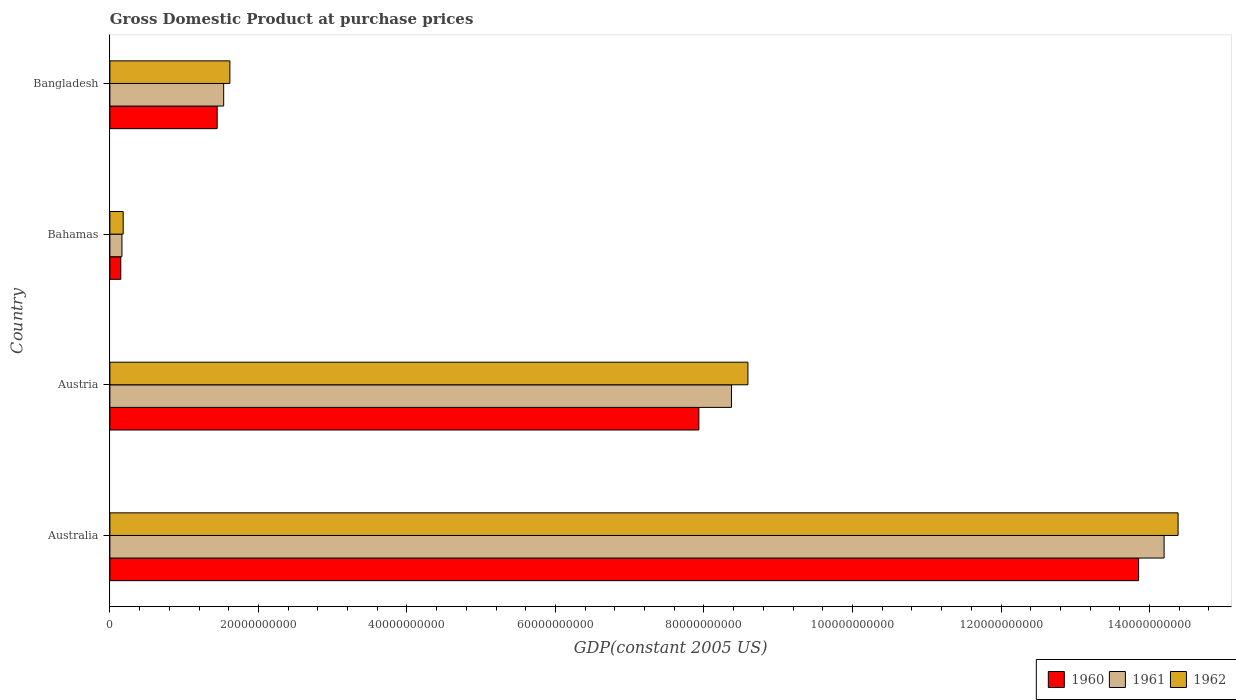How many different coloured bars are there?
Make the answer very short. 3. Are the number of bars per tick equal to the number of legend labels?
Ensure brevity in your answer.  Yes. How many bars are there on the 2nd tick from the top?
Offer a very short reply. 3. What is the label of the 1st group of bars from the top?
Give a very brief answer. Bangladesh. In how many cases, is the number of bars for a given country not equal to the number of legend labels?
Ensure brevity in your answer.  0. What is the GDP at purchase prices in 1960 in Bangladesh?
Offer a terse response. 1.44e+1. Across all countries, what is the maximum GDP at purchase prices in 1962?
Make the answer very short. 1.44e+11. Across all countries, what is the minimum GDP at purchase prices in 1962?
Ensure brevity in your answer.  1.79e+09. In which country was the GDP at purchase prices in 1962 minimum?
Offer a very short reply. Bahamas. What is the total GDP at purchase prices in 1962 in the graph?
Give a very brief answer. 2.48e+11. What is the difference between the GDP at purchase prices in 1960 in Australia and that in Bangladesh?
Offer a terse response. 1.24e+11. What is the difference between the GDP at purchase prices in 1960 in Bahamas and the GDP at purchase prices in 1962 in Australia?
Your answer should be very brief. -1.42e+11. What is the average GDP at purchase prices in 1962 per country?
Offer a very short reply. 6.19e+1. What is the difference between the GDP at purchase prices in 1960 and GDP at purchase prices in 1961 in Bangladesh?
Provide a succinct answer. -8.75e+08. In how many countries, is the GDP at purchase prices in 1961 greater than 24000000000 US$?
Give a very brief answer. 2. What is the ratio of the GDP at purchase prices in 1962 in Austria to that in Bangladesh?
Your response must be concise. 5.32. Is the GDP at purchase prices in 1960 in Australia less than that in Austria?
Your response must be concise. No. What is the difference between the highest and the second highest GDP at purchase prices in 1962?
Keep it short and to the point. 5.79e+1. What is the difference between the highest and the lowest GDP at purchase prices in 1962?
Your answer should be compact. 1.42e+11. What does the 3rd bar from the top in Australia represents?
Your answer should be very brief. 1960. What does the 3rd bar from the bottom in Bahamas represents?
Provide a short and direct response. 1962. Is it the case that in every country, the sum of the GDP at purchase prices in 1961 and GDP at purchase prices in 1962 is greater than the GDP at purchase prices in 1960?
Provide a succinct answer. Yes. Are all the bars in the graph horizontal?
Your answer should be compact. Yes. How many countries are there in the graph?
Provide a short and direct response. 4. What is the difference between two consecutive major ticks on the X-axis?
Keep it short and to the point. 2.00e+1. Are the values on the major ticks of X-axis written in scientific E-notation?
Your answer should be compact. No. Does the graph contain any zero values?
Offer a terse response. No. Does the graph contain grids?
Your answer should be very brief. No. Where does the legend appear in the graph?
Your answer should be very brief. Bottom right. What is the title of the graph?
Keep it short and to the point. Gross Domestic Product at purchase prices. Does "1960" appear as one of the legend labels in the graph?
Keep it short and to the point. Yes. What is the label or title of the X-axis?
Keep it short and to the point. GDP(constant 2005 US). What is the GDP(constant 2005 US) in 1960 in Australia?
Keep it short and to the point. 1.39e+11. What is the GDP(constant 2005 US) of 1961 in Australia?
Ensure brevity in your answer.  1.42e+11. What is the GDP(constant 2005 US) of 1962 in Australia?
Offer a terse response. 1.44e+11. What is the GDP(constant 2005 US) in 1960 in Austria?
Offer a terse response. 7.93e+1. What is the GDP(constant 2005 US) of 1961 in Austria?
Give a very brief answer. 8.37e+1. What is the GDP(constant 2005 US) in 1962 in Austria?
Make the answer very short. 8.59e+1. What is the GDP(constant 2005 US) of 1960 in Bahamas?
Your response must be concise. 1.47e+09. What is the GDP(constant 2005 US) in 1961 in Bahamas?
Your answer should be compact. 1.62e+09. What is the GDP(constant 2005 US) of 1962 in Bahamas?
Your answer should be very brief. 1.79e+09. What is the GDP(constant 2005 US) in 1960 in Bangladesh?
Keep it short and to the point. 1.44e+1. What is the GDP(constant 2005 US) of 1961 in Bangladesh?
Your response must be concise. 1.53e+1. What is the GDP(constant 2005 US) of 1962 in Bangladesh?
Offer a very short reply. 1.62e+1. Across all countries, what is the maximum GDP(constant 2005 US) of 1960?
Give a very brief answer. 1.39e+11. Across all countries, what is the maximum GDP(constant 2005 US) of 1961?
Your response must be concise. 1.42e+11. Across all countries, what is the maximum GDP(constant 2005 US) of 1962?
Keep it short and to the point. 1.44e+11. Across all countries, what is the minimum GDP(constant 2005 US) of 1960?
Your response must be concise. 1.47e+09. Across all countries, what is the minimum GDP(constant 2005 US) of 1961?
Provide a succinct answer. 1.62e+09. Across all countries, what is the minimum GDP(constant 2005 US) of 1962?
Ensure brevity in your answer.  1.79e+09. What is the total GDP(constant 2005 US) of 1960 in the graph?
Keep it short and to the point. 2.34e+11. What is the total GDP(constant 2005 US) of 1961 in the graph?
Your answer should be very brief. 2.43e+11. What is the total GDP(constant 2005 US) in 1962 in the graph?
Offer a very short reply. 2.48e+11. What is the difference between the GDP(constant 2005 US) in 1960 in Australia and that in Austria?
Offer a very short reply. 5.92e+1. What is the difference between the GDP(constant 2005 US) in 1961 in Australia and that in Austria?
Ensure brevity in your answer.  5.83e+1. What is the difference between the GDP(constant 2005 US) in 1962 in Australia and that in Austria?
Your answer should be very brief. 5.79e+1. What is the difference between the GDP(constant 2005 US) in 1960 in Australia and that in Bahamas?
Keep it short and to the point. 1.37e+11. What is the difference between the GDP(constant 2005 US) of 1961 in Australia and that in Bahamas?
Offer a terse response. 1.40e+11. What is the difference between the GDP(constant 2005 US) in 1962 in Australia and that in Bahamas?
Provide a short and direct response. 1.42e+11. What is the difference between the GDP(constant 2005 US) in 1960 in Australia and that in Bangladesh?
Provide a short and direct response. 1.24e+11. What is the difference between the GDP(constant 2005 US) of 1961 in Australia and that in Bangladesh?
Give a very brief answer. 1.27e+11. What is the difference between the GDP(constant 2005 US) in 1962 in Australia and that in Bangladesh?
Provide a short and direct response. 1.28e+11. What is the difference between the GDP(constant 2005 US) of 1960 in Austria and that in Bahamas?
Offer a terse response. 7.78e+1. What is the difference between the GDP(constant 2005 US) of 1961 in Austria and that in Bahamas?
Your answer should be very brief. 8.21e+1. What is the difference between the GDP(constant 2005 US) of 1962 in Austria and that in Bahamas?
Make the answer very short. 8.41e+1. What is the difference between the GDP(constant 2005 US) in 1960 in Austria and that in Bangladesh?
Offer a terse response. 6.49e+1. What is the difference between the GDP(constant 2005 US) in 1961 in Austria and that in Bangladesh?
Provide a succinct answer. 6.84e+1. What is the difference between the GDP(constant 2005 US) in 1962 in Austria and that in Bangladesh?
Your answer should be very brief. 6.98e+1. What is the difference between the GDP(constant 2005 US) of 1960 in Bahamas and that in Bangladesh?
Give a very brief answer. -1.30e+1. What is the difference between the GDP(constant 2005 US) of 1961 in Bahamas and that in Bangladesh?
Keep it short and to the point. -1.37e+1. What is the difference between the GDP(constant 2005 US) of 1962 in Bahamas and that in Bangladesh?
Make the answer very short. -1.44e+1. What is the difference between the GDP(constant 2005 US) of 1960 in Australia and the GDP(constant 2005 US) of 1961 in Austria?
Provide a succinct answer. 5.48e+1. What is the difference between the GDP(constant 2005 US) of 1960 in Australia and the GDP(constant 2005 US) of 1962 in Austria?
Your response must be concise. 5.26e+1. What is the difference between the GDP(constant 2005 US) in 1961 in Australia and the GDP(constant 2005 US) in 1962 in Austria?
Provide a succinct answer. 5.60e+1. What is the difference between the GDP(constant 2005 US) in 1960 in Australia and the GDP(constant 2005 US) in 1961 in Bahamas?
Offer a terse response. 1.37e+11. What is the difference between the GDP(constant 2005 US) of 1960 in Australia and the GDP(constant 2005 US) of 1962 in Bahamas?
Keep it short and to the point. 1.37e+11. What is the difference between the GDP(constant 2005 US) of 1961 in Australia and the GDP(constant 2005 US) of 1962 in Bahamas?
Offer a terse response. 1.40e+11. What is the difference between the GDP(constant 2005 US) in 1960 in Australia and the GDP(constant 2005 US) in 1961 in Bangladesh?
Ensure brevity in your answer.  1.23e+11. What is the difference between the GDP(constant 2005 US) in 1960 in Australia and the GDP(constant 2005 US) in 1962 in Bangladesh?
Keep it short and to the point. 1.22e+11. What is the difference between the GDP(constant 2005 US) of 1961 in Australia and the GDP(constant 2005 US) of 1962 in Bangladesh?
Provide a short and direct response. 1.26e+11. What is the difference between the GDP(constant 2005 US) of 1960 in Austria and the GDP(constant 2005 US) of 1961 in Bahamas?
Offer a terse response. 7.77e+1. What is the difference between the GDP(constant 2005 US) in 1960 in Austria and the GDP(constant 2005 US) in 1962 in Bahamas?
Offer a very short reply. 7.75e+1. What is the difference between the GDP(constant 2005 US) of 1961 in Austria and the GDP(constant 2005 US) of 1962 in Bahamas?
Provide a short and direct response. 8.19e+1. What is the difference between the GDP(constant 2005 US) in 1960 in Austria and the GDP(constant 2005 US) in 1961 in Bangladesh?
Your answer should be very brief. 6.40e+1. What is the difference between the GDP(constant 2005 US) in 1960 in Austria and the GDP(constant 2005 US) in 1962 in Bangladesh?
Your response must be concise. 6.32e+1. What is the difference between the GDP(constant 2005 US) in 1961 in Austria and the GDP(constant 2005 US) in 1962 in Bangladesh?
Ensure brevity in your answer.  6.75e+1. What is the difference between the GDP(constant 2005 US) of 1960 in Bahamas and the GDP(constant 2005 US) of 1961 in Bangladesh?
Your response must be concise. -1.39e+1. What is the difference between the GDP(constant 2005 US) of 1960 in Bahamas and the GDP(constant 2005 US) of 1962 in Bangladesh?
Your answer should be compact. -1.47e+1. What is the difference between the GDP(constant 2005 US) of 1961 in Bahamas and the GDP(constant 2005 US) of 1962 in Bangladesh?
Your answer should be compact. -1.45e+1. What is the average GDP(constant 2005 US) in 1960 per country?
Your answer should be compact. 5.84e+1. What is the average GDP(constant 2005 US) in 1961 per country?
Offer a very short reply. 6.06e+1. What is the average GDP(constant 2005 US) of 1962 per country?
Keep it short and to the point. 6.19e+1. What is the difference between the GDP(constant 2005 US) of 1960 and GDP(constant 2005 US) of 1961 in Australia?
Provide a succinct answer. -3.43e+09. What is the difference between the GDP(constant 2005 US) of 1960 and GDP(constant 2005 US) of 1962 in Australia?
Offer a very short reply. -5.31e+09. What is the difference between the GDP(constant 2005 US) of 1961 and GDP(constant 2005 US) of 1962 in Australia?
Keep it short and to the point. -1.88e+09. What is the difference between the GDP(constant 2005 US) of 1960 and GDP(constant 2005 US) of 1961 in Austria?
Make the answer very short. -4.39e+09. What is the difference between the GDP(constant 2005 US) in 1960 and GDP(constant 2005 US) in 1962 in Austria?
Your answer should be compact. -6.61e+09. What is the difference between the GDP(constant 2005 US) of 1961 and GDP(constant 2005 US) of 1962 in Austria?
Offer a terse response. -2.22e+09. What is the difference between the GDP(constant 2005 US) of 1960 and GDP(constant 2005 US) of 1961 in Bahamas?
Keep it short and to the point. -1.56e+08. What is the difference between the GDP(constant 2005 US) in 1960 and GDP(constant 2005 US) in 1962 in Bahamas?
Give a very brief answer. -3.26e+08. What is the difference between the GDP(constant 2005 US) of 1961 and GDP(constant 2005 US) of 1962 in Bahamas?
Make the answer very short. -1.70e+08. What is the difference between the GDP(constant 2005 US) of 1960 and GDP(constant 2005 US) of 1961 in Bangladesh?
Your response must be concise. -8.75e+08. What is the difference between the GDP(constant 2005 US) in 1960 and GDP(constant 2005 US) in 1962 in Bangladesh?
Offer a very short reply. -1.71e+09. What is the difference between the GDP(constant 2005 US) in 1961 and GDP(constant 2005 US) in 1962 in Bangladesh?
Offer a very short reply. -8.36e+08. What is the ratio of the GDP(constant 2005 US) of 1960 in Australia to that in Austria?
Your answer should be compact. 1.75. What is the ratio of the GDP(constant 2005 US) of 1961 in Australia to that in Austria?
Your response must be concise. 1.7. What is the ratio of the GDP(constant 2005 US) in 1962 in Australia to that in Austria?
Ensure brevity in your answer.  1.67. What is the ratio of the GDP(constant 2005 US) of 1960 in Australia to that in Bahamas?
Keep it short and to the point. 94.52. What is the ratio of the GDP(constant 2005 US) in 1961 in Australia to that in Bahamas?
Provide a succinct answer. 87.52. What is the ratio of the GDP(constant 2005 US) of 1962 in Australia to that in Bahamas?
Provide a succinct answer. 80.29. What is the ratio of the GDP(constant 2005 US) in 1960 in Australia to that in Bangladesh?
Make the answer very short. 9.59. What is the ratio of the GDP(constant 2005 US) in 1961 in Australia to that in Bangladesh?
Provide a short and direct response. 9.26. What is the ratio of the GDP(constant 2005 US) of 1962 in Australia to that in Bangladesh?
Your answer should be compact. 8.9. What is the ratio of the GDP(constant 2005 US) of 1960 in Austria to that in Bahamas?
Offer a terse response. 54.11. What is the ratio of the GDP(constant 2005 US) in 1961 in Austria to that in Bahamas?
Make the answer very short. 51.61. What is the ratio of the GDP(constant 2005 US) of 1962 in Austria to that in Bahamas?
Your answer should be compact. 47.96. What is the ratio of the GDP(constant 2005 US) in 1960 in Austria to that in Bangladesh?
Provide a succinct answer. 5.49. What is the ratio of the GDP(constant 2005 US) of 1961 in Austria to that in Bangladesh?
Your answer should be compact. 5.46. What is the ratio of the GDP(constant 2005 US) of 1962 in Austria to that in Bangladesh?
Provide a succinct answer. 5.32. What is the ratio of the GDP(constant 2005 US) in 1960 in Bahamas to that in Bangladesh?
Make the answer very short. 0.1. What is the ratio of the GDP(constant 2005 US) of 1961 in Bahamas to that in Bangladesh?
Your answer should be compact. 0.11. What is the ratio of the GDP(constant 2005 US) in 1962 in Bahamas to that in Bangladesh?
Offer a very short reply. 0.11. What is the difference between the highest and the second highest GDP(constant 2005 US) of 1960?
Your answer should be very brief. 5.92e+1. What is the difference between the highest and the second highest GDP(constant 2005 US) of 1961?
Your answer should be very brief. 5.83e+1. What is the difference between the highest and the second highest GDP(constant 2005 US) in 1962?
Offer a very short reply. 5.79e+1. What is the difference between the highest and the lowest GDP(constant 2005 US) in 1960?
Offer a very short reply. 1.37e+11. What is the difference between the highest and the lowest GDP(constant 2005 US) of 1961?
Your response must be concise. 1.40e+11. What is the difference between the highest and the lowest GDP(constant 2005 US) of 1962?
Give a very brief answer. 1.42e+11. 